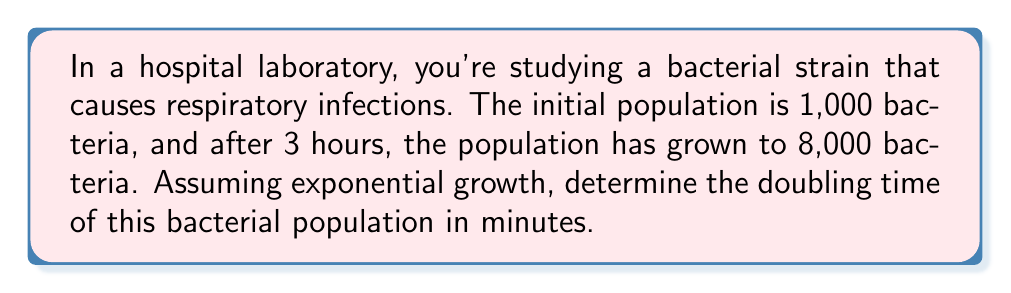Provide a solution to this math problem. Let's approach this step-by-step:

1) The exponential growth formula is:
   $$N(t) = N_0 \cdot 2^{\frac{t}{d}}$$
   Where $N(t)$ is the population at time $t$, $N_0$ is the initial population, $t$ is the time elapsed, and $d$ is the doubling time.

2) We know:
   $N_0 = 1,000$
   $N(t) = 8,000$
   $t = 3$ hours = 180 minutes

3) Plugging these into our formula:
   $$8,000 = 1,000 \cdot 2^{\frac{180}{d}}$$

4) Simplify:
   $$8 = 2^{\frac{180}{d}}$$

5) Take $\log_2$ of both sides:
   $$\log_2(8) = \frac{180}{d}$$

6) Simplify $\log_2(8)$:
   $$3 = \frac{180}{d}$$

7) Solve for $d$:
   $$d = \frac{180}{3} = 60$$

Therefore, the doubling time is 60 minutes.
Answer: 60 minutes 